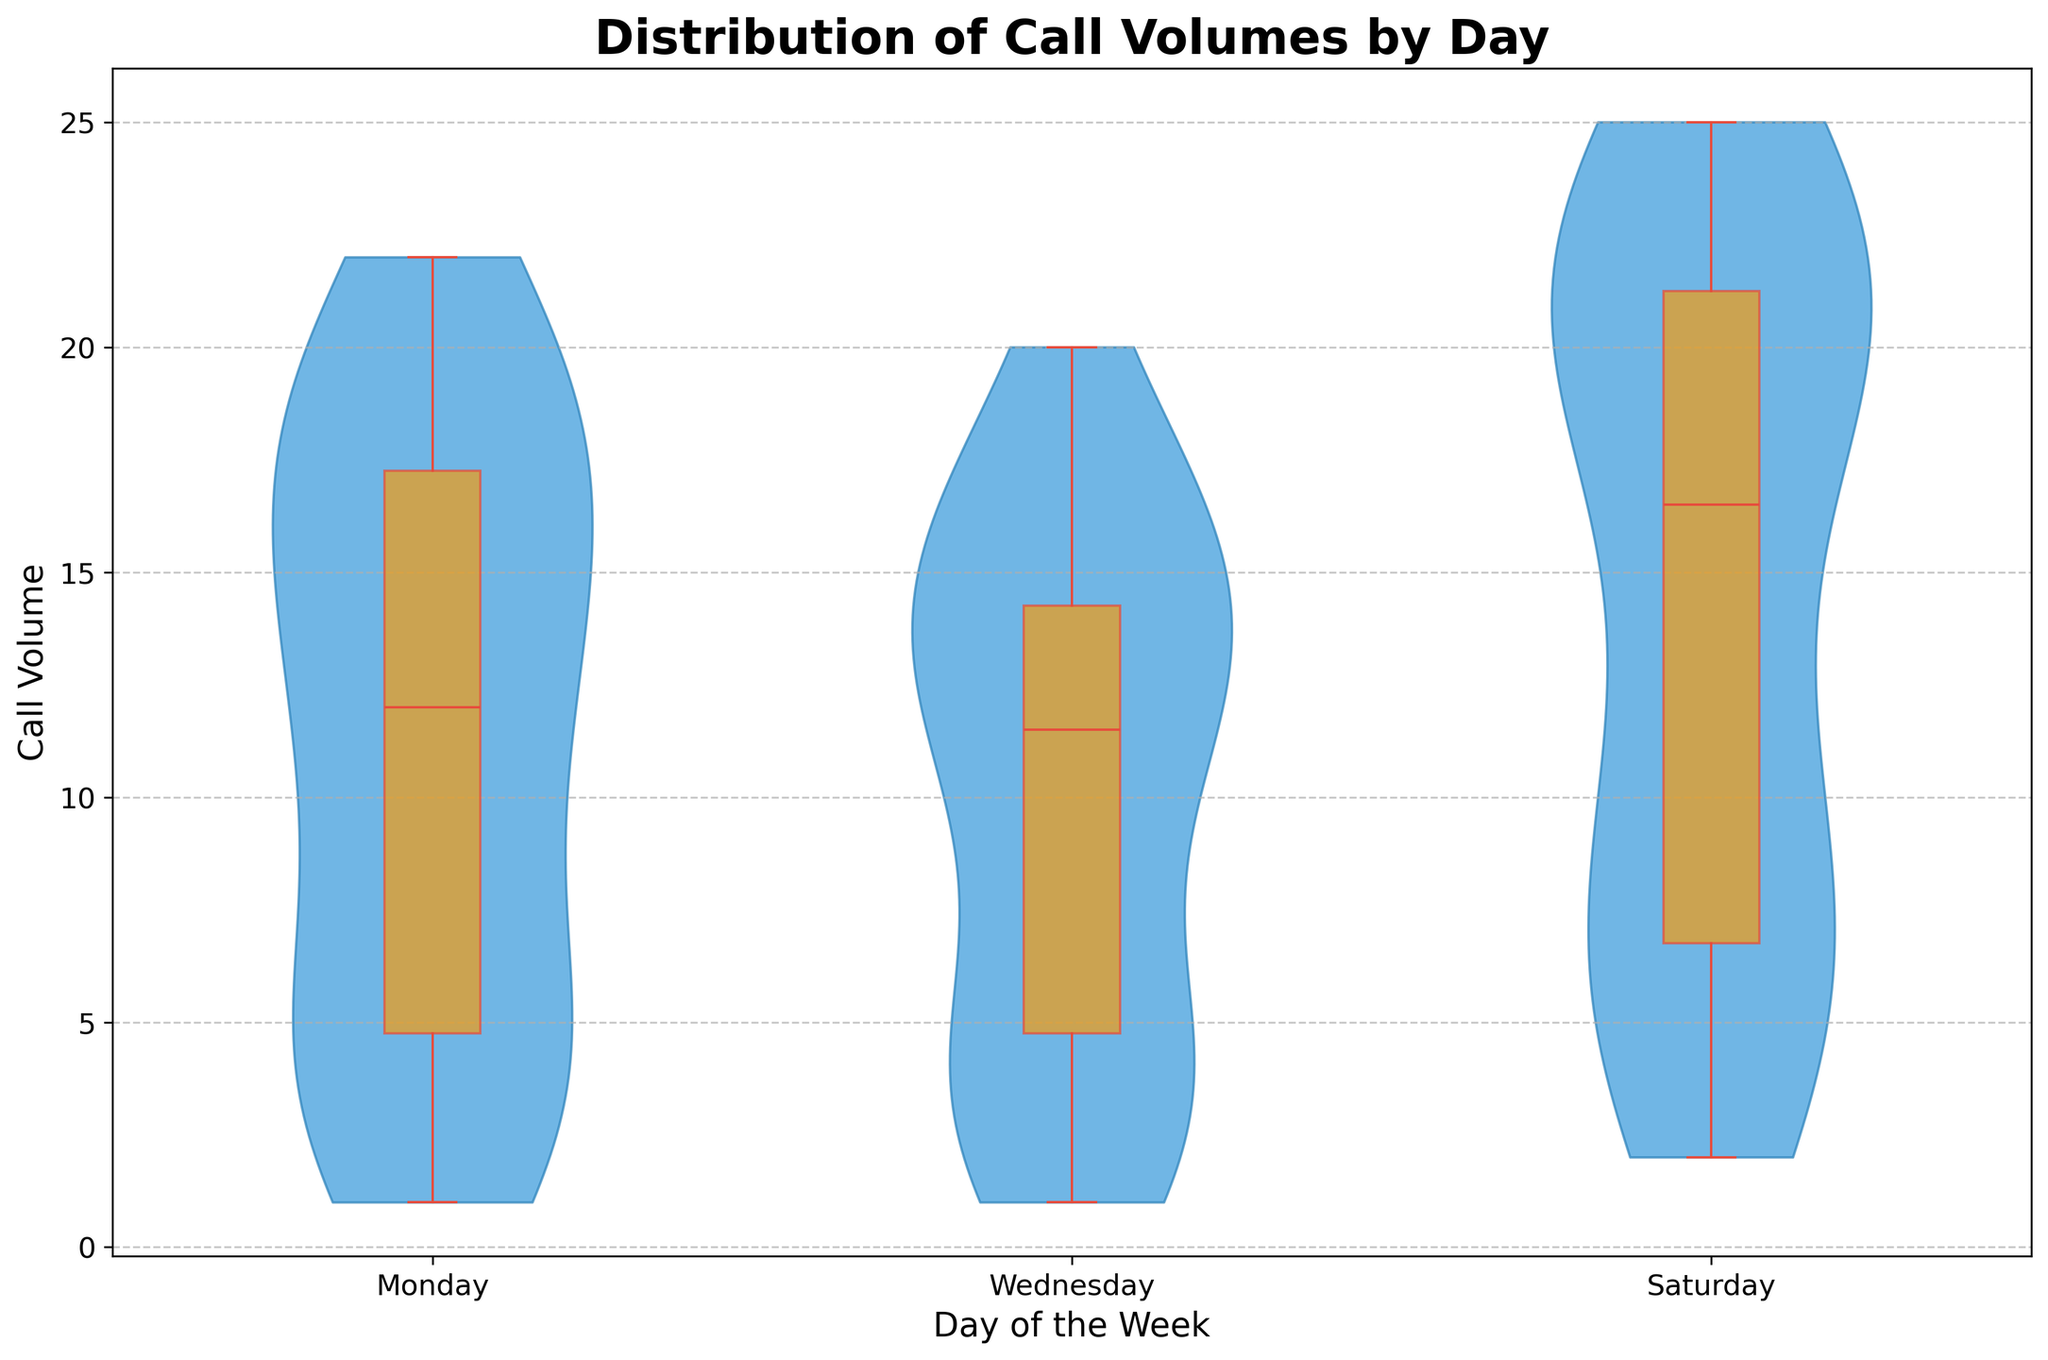What's the title of the figure? The title is typically located at the top center of the figure. In this case, it reads "Distribution of Call Volumes by Day".
Answer: Distribution of Call Volumes by Day What days of the week are represented in the figure? The x-axis of the figure lists all the represented days. They are labeled sequentially from left to right.
Answer: Monday, Wednesday, Saturday What is the maximum call volume on Wednesday? The highest point of the box plot and violin distribution for Wednesday will signify the maximum call volume. The maximum value appears at 20.
Answer: 20 At what time does the call volume peak on Saturday? By examining the violin distribution and box plot overlay for Saturday, you can see the peak call volume around 12:00 PM, reaching up to 25.
Answer: 12:00 PM Which day has the most variation in call volumes? The day with the widest spread in the violin plot and box plot whiskers indicates the most variation. By comparing all the days, it appears that Saturday has the widest distribution.
Answer: Saturday How does the median call volume compare between Monday and Saturday? The median is typically marked by the line within the box of the box plot. On Saturday, it seems the median is higher than on Monday. Specifically, Saturday's median is around 19, while Monday's is around 15.
Answer: Saturday's median is higher What is the range of call volumes on Monday? The range can be calculated from the lowest to highest points in the violin plot and box plot whiskers. For Monday, the lowest call volume is 1 and the highest is 22.
Answer: 1 to 22 During what time period do Mondays experience the lowest volumes of calls? The violin and box plots for the times on Monday show the lowest call volumes. The early hours (04:00 AM) have the least calls, around 1.
Answer: 04:00 AM Which day exhibits a more uniform distribution of call volumes throughout the day? A more uniform distribution will have a less varied violin plot and closer box plot ranges. Wednesday seems to have a more consistent number of calls across different times.
Answer: Wednesday 